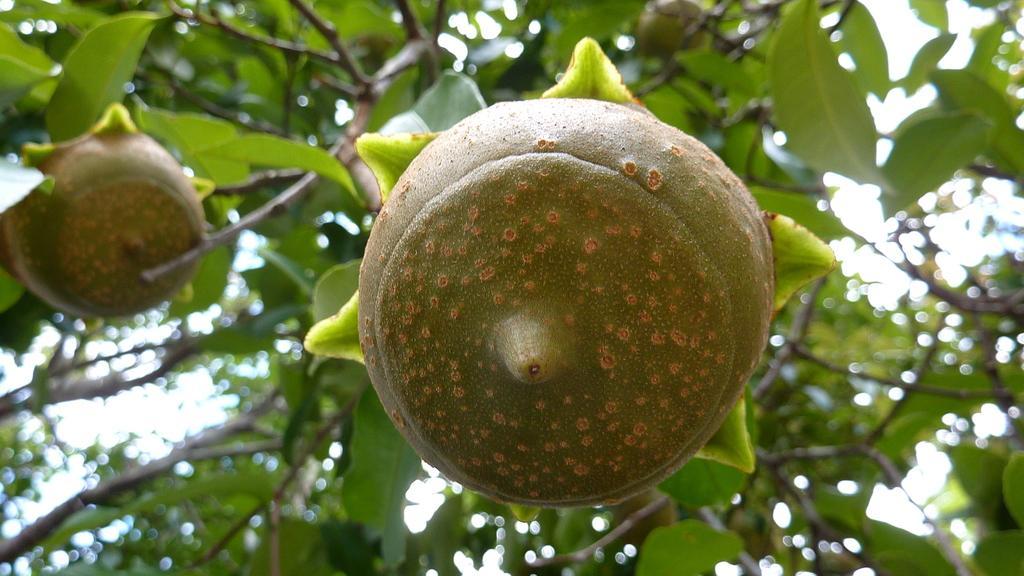In one or two sentences, can you explain what this image depicts? In the image we can see some fruits and plants. 